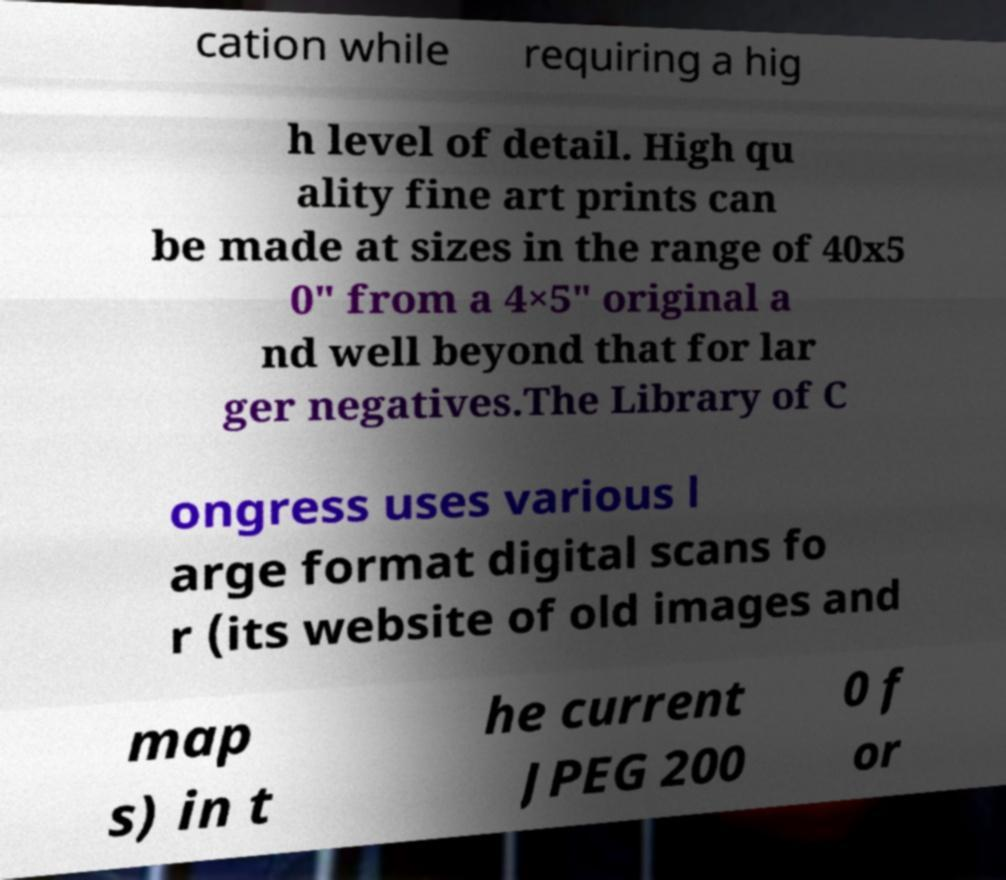I need the written content from this picture converted into text. Can you do that? cation while requiring a hig h level of detail. High qu ality fine art prints can be made at sizes in the range of 40x5 0″ from a 4×5″ original a nd well beyond that for lar ger negatives.The Library of C ongress uses various l arge format digital scans fo r (its website of old images and map s) in t he current JPEG 200 0 f or 